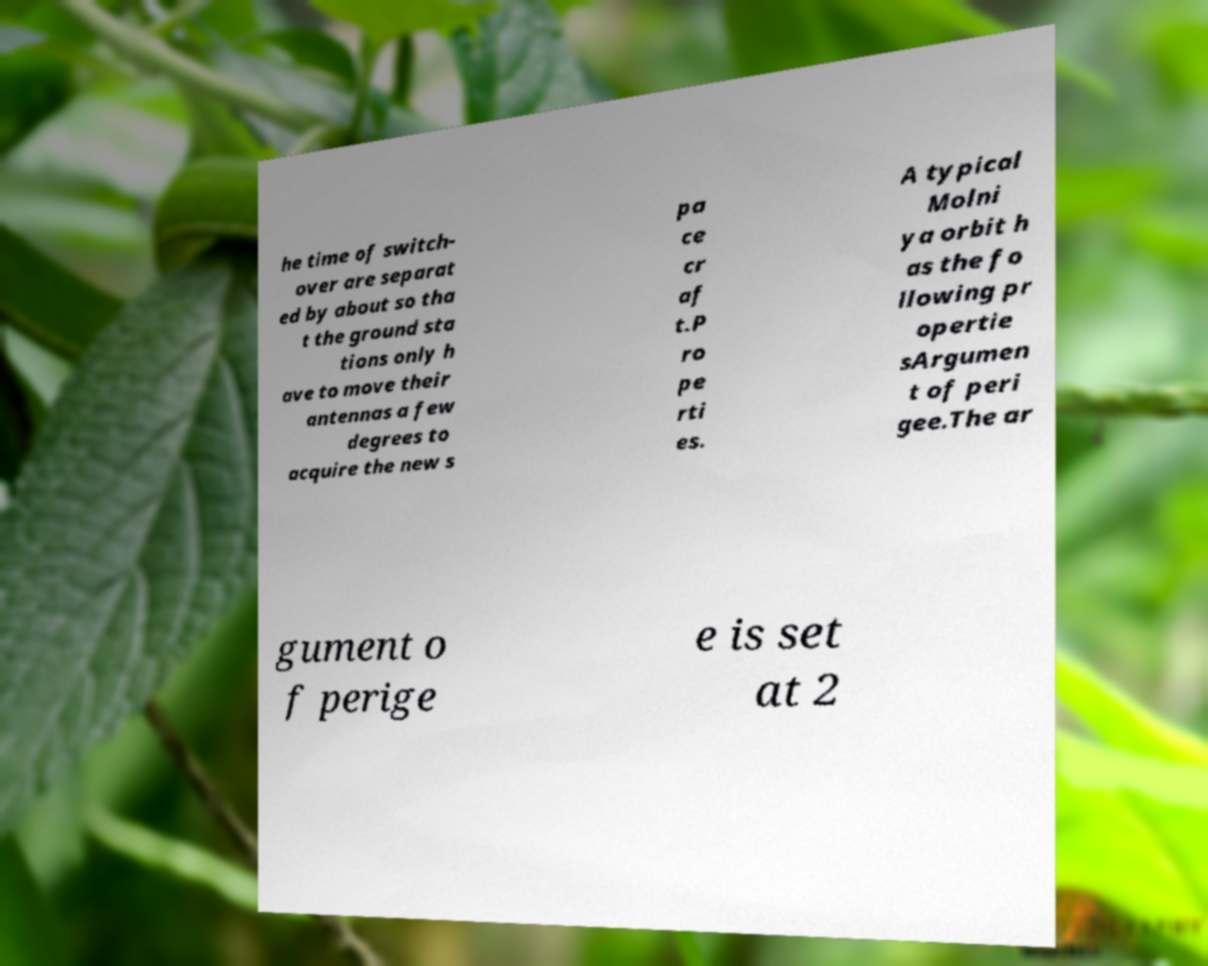For documentation purposes, I need the text within this image transcribed. Could you provide that? he time of switch- over are separat ed by about so tha t the ground sta tions only h ave to move their antennas a few degrees to acquire the new s pa ce cr af t.P ro pe rti es. A typical Molni ya orbit h as the fo llowing pr opertie sArgumen t of peri gee.The ar gument o f perige e is set at 2 